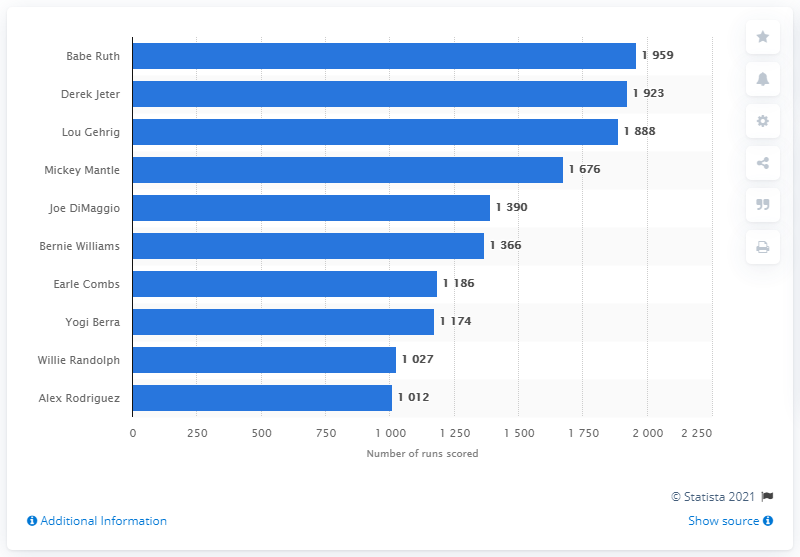Draw attention to some important aspects in this diagram. Babe Ruth is the player who has scored the most runs in the history of the New York Yankees franchise. 